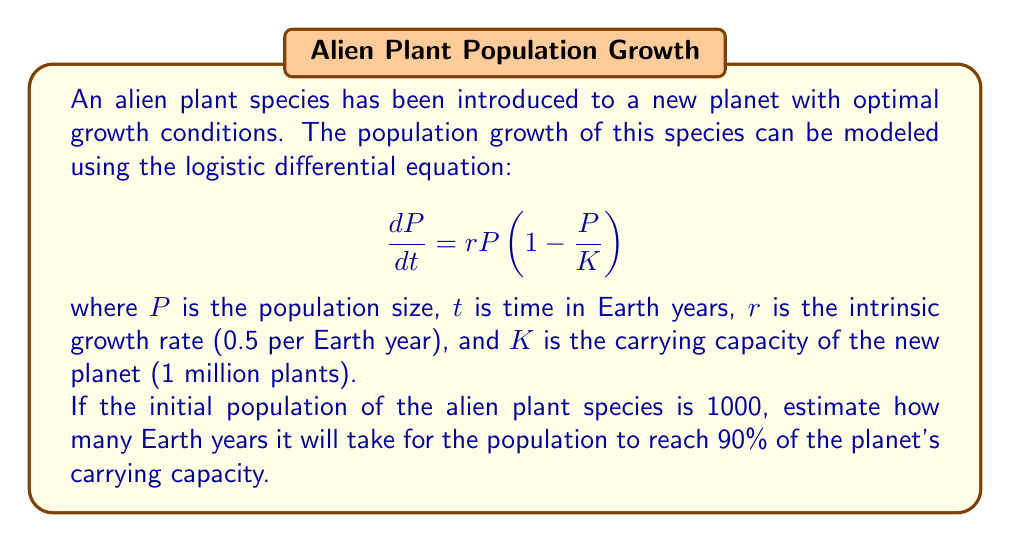Teach me how to tackle this problem. To solve this problem, we need to integrate the logistic differential equation and solve for time. Let's break it down step-by-step:

1) The logistic differential equation is:

   $$\frac{dP}{dt} = rP\left(1 - \frac{P}{K}\right)$$

2) We can separate the variables and integrate:

   $$\int_{P_0}^P \frac{dP}{P(1-P/K)} = \int_0^t r dt$$

3) The left-hand side can be integrated using partial fractions:

   $$\left[\ln(P) - \ln(K-P)\right]_{P_0}^P = rt$$

4) Evaluating the integral:

   $$\ln\left(\frac{P}{K-P}\right) - \ln\left(\frac{P_0}{K-P_0}\right) = rt$$

5) Simplifying and solving for $t$:

   $$t = \frac{1}{r}\ln\left(\frac{P(K-P_0)}{P_0(K-P)}\right)$$

6) Now, let's plug in our values:
   - $P_0 = 1000$ (initial population)
   - $K = 1,000,000$ (carrying capacity)
   - $r = 0.5$ (growth rate)
   - $P = 0.9K = 900,000$ (90% of carrying capacity)

7) Substituting these values:

   $$t = \frac{1}{0.5}\ln\left(\frac{900,000(1,000,000-1000)}{1000(1,000,000-900,000)}\right)$$

8) Simplifying:

   $$t = 2\ln\left(\frac{900,000 \times 999,000}{1000 \times 100,000}\right) = 2\ln(8991) \approx 18.19$$

Therefore, it will take approximately 18.19 Earth years for the alien plant species to reach 90% of the planet's carrying capacity.
Answer: Approximately 18.19 Earth years 